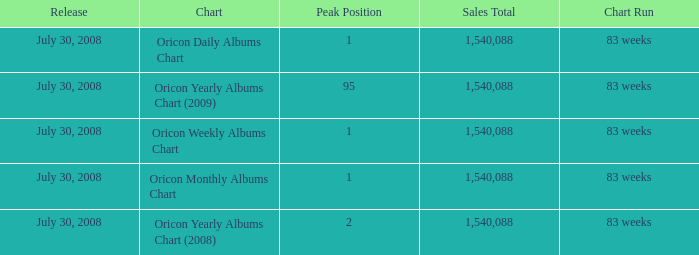Which Sales Total has a Chart of oricon monthly albums chart? 1540088.0. 